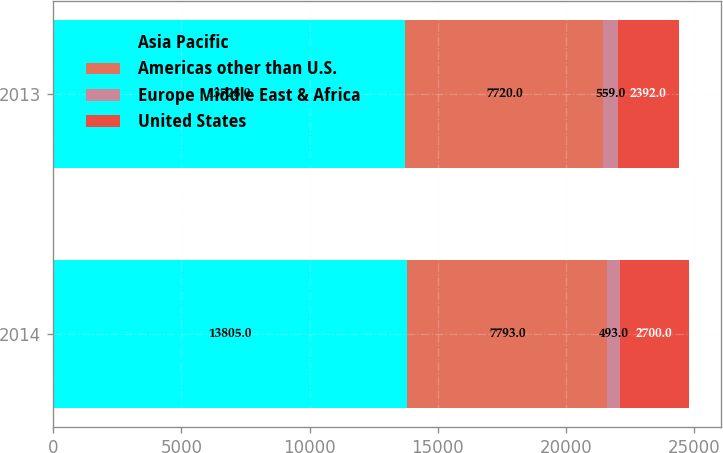<chart> <loc_0><loc_0><loc_500><loc_500><stacked_bar_chart><ecel><fcel>2014<fcel>2013<nl><fcel>Asia Pacific<fcel>13805<fcel>13728<nl><fcel>Americas other than U.S.<fcel>7793<fcel>7720<nl><fcel>Europe Middle East & Africa<fcel>493<fcel>559<nl><fcel>United States<fcel>2700<fcel>2392<nl></chart> 